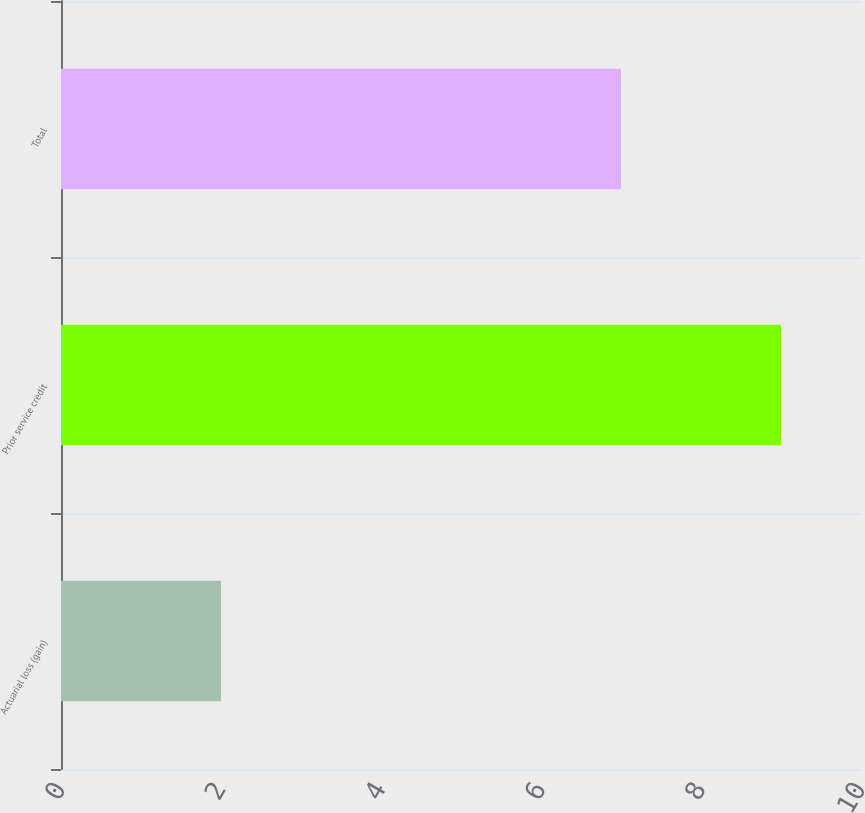<chart> <loc_0><loc_0><loc_500><loc_500><bar_chart><fcel>Actuarial loss (gain)<fcel>Prior service credit<fcel>Total<nl><fcel>2<fcel>9<fcel>7<nl></chart> 